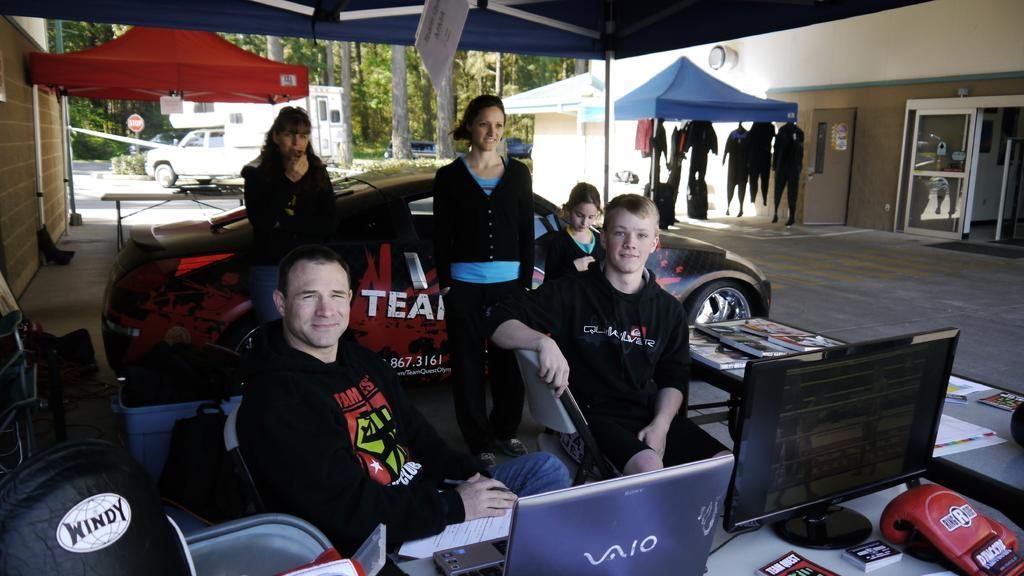Please provide a concise description of this image. In the foreground I can see two persons are sitting on the chairs in front of a desk on which I can see laptops, cards, system and so on. In the background I can see three persons are standing on the floor, car, tents, clothes are hanged, buildings, vehicles and trees. This image is taken may be during a day. 